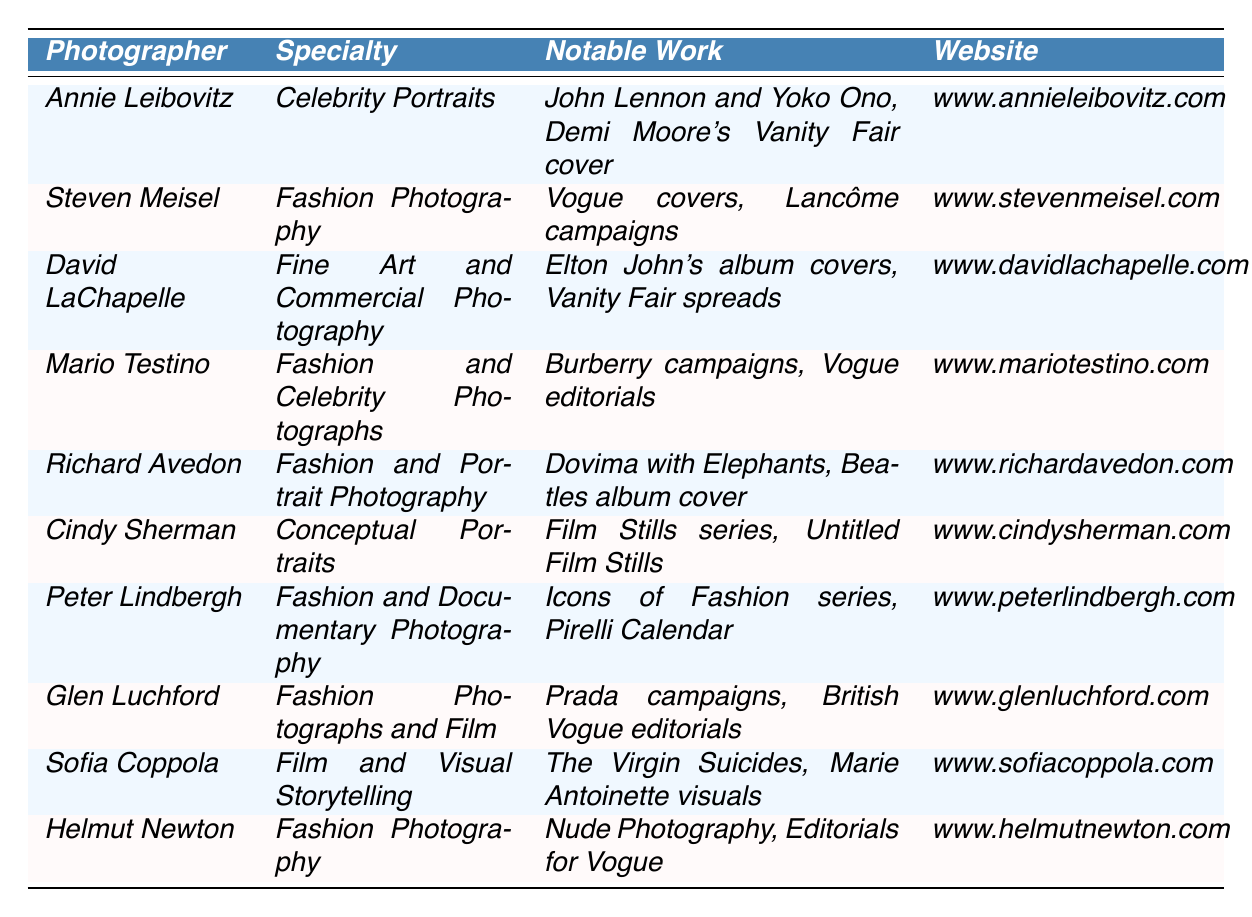What is the specialty of Annie Leibovitz? The table lists Annie Leibovitz's specialty as "Celebrity Portraits."
Answer: Celebrity Portraits Which notable work is associated with Steven Meisel? The table specifies that Steven Meisel's notable works include "Vogue covers" and "Lancôme campaigns."
Answer: Vogue covers and Lancôme campaigns How many photographers specialize in Fashion Photography? By reviewing the table, it is noted that both Steven Meisel, Mario Testino, Richard Avedon, and Helmut Newton are specified as "Fashion Photography" specialists, leading to a total of 4 photographers.
Answer: 4 Is David LaChapelle known for Commercial Photography? The table indicates that David LaChapelle specializes in "Fine Art and Commercial Photography," which confirms that he is indeed known for Commercial Photography.
Answer: Yes What is the average number of notable works across the photographers listed? The table details notable works for 10 photographers, and while not explicitly quantifying the items, one could summarize that each photographer has at least one notable work listed, thus suggesting an average of 1 notable work per photographer listed here, making the average 1.
Answer: 1 Which photographer has worked with Elton John? Looking in the table, it specifies that David LaChapelle is noted for "Elton John's album covers" among his notable works, indicating he has worked with Elton John.
Answer: David LaChapelle Can you name a photographer who has worked on Vogue editorials? According to the table, both Mario Testino and Glen Luchford have notable works that involve "Vogue editorials."
Answer: Mario Testino and Glen Luchford How does the specialty of Sofia Coppola differ from the other photographers? The table shows Sofia Coppola's specialty as "Film and Visual Storytelling," whereas the others primarily focus on different forms of photography, making her specialty unique in this context.
Answer: Unique specialty in Film and Visual Storytelling Which photographer has a notable work called "Dovima with Elephants"? The table indicates that "Dovima with Elephants" is a notable work for Richard Avedon.
Answer: Richard Avedon Is there a photographer who specializes in Conceptual Portraits and what is their website? The table confirms that Cindy Sherman specializes in "Conceptual Portraits," and her website is listed as "www.cindysherman.com."
Answer: Yes, Cindy Sherman; www.cindysherman.com 